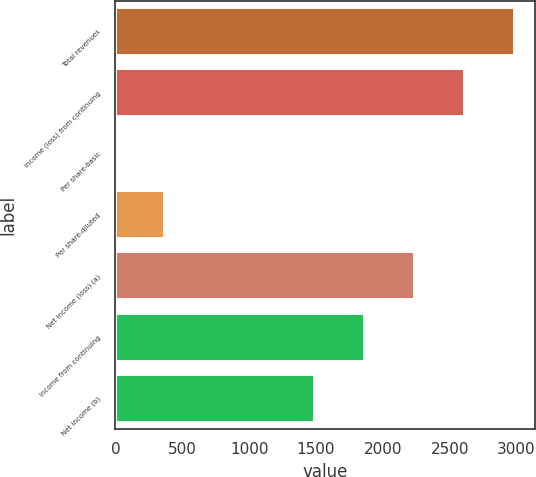<chart> <loc_0><loc_0><loc_500><loc_500><bar_chart><fcel>Total revenues<fcel>Income (loss) from continuing<fcel>Per share-basic<fcel>Per share-diluted<fcel>Net income (loss) (a)<fcel>Income from continuing<fcel>Net income (b)<nl><fcel>2990.49<fcel>2616.72<fcel>0.33<fcel>374.1<fcel>2242.95<fcel>1869.18<fcel>1495.41<nl></chart> 